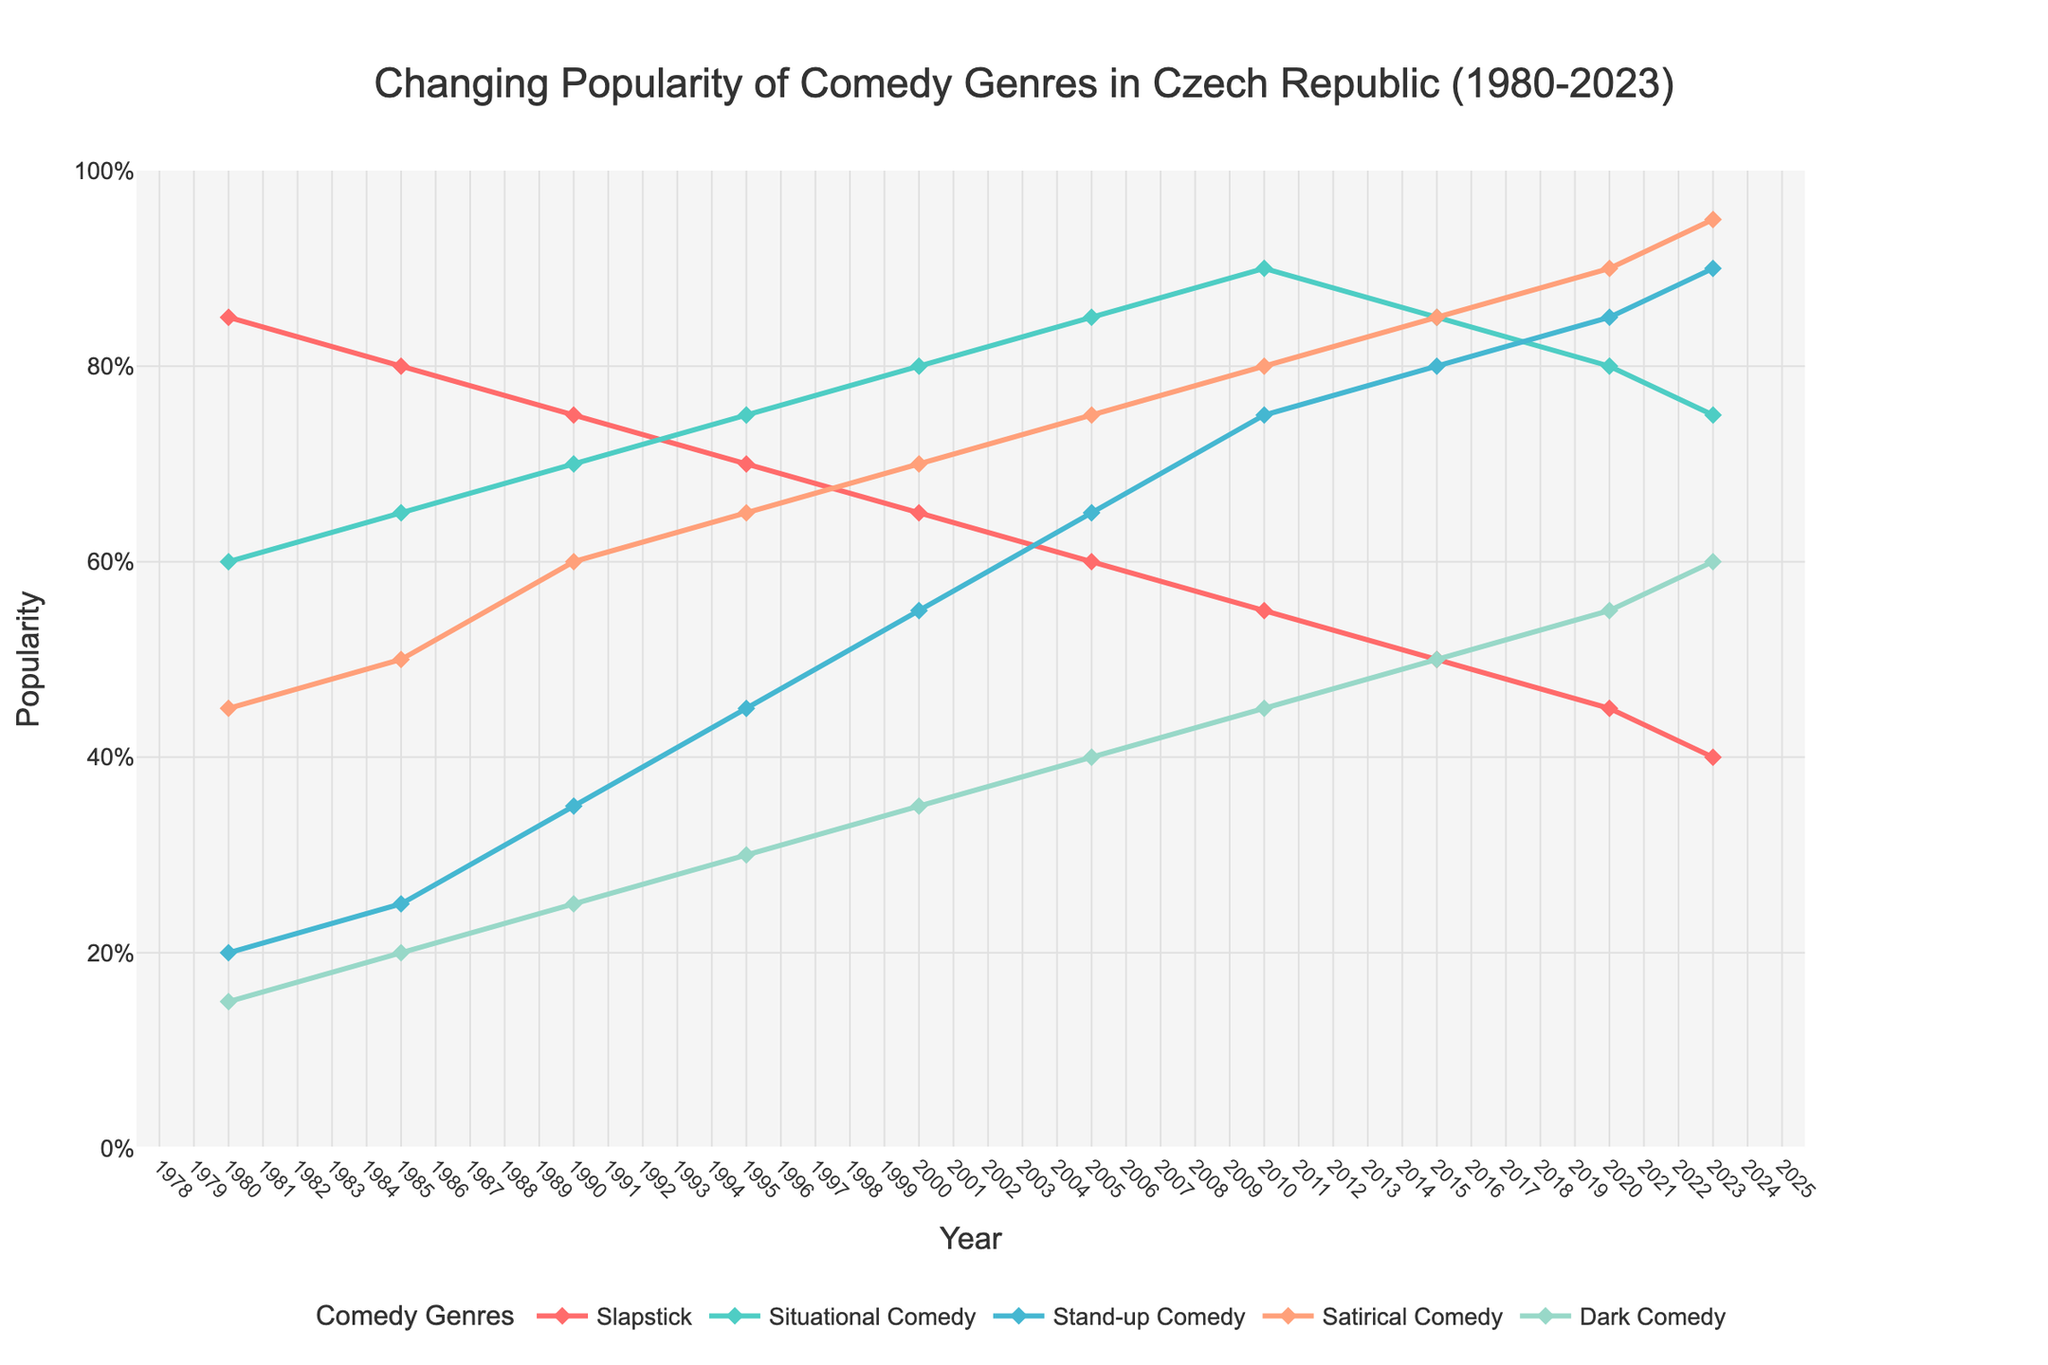What genre shows a steady decline in popularity from 1980 to 2023? Slapstick comedy. Its popularity decreases from 85% in 1980 to 40% in 2023.
Answer: Slapstick Comedy Which comedy genre was the most popular in 1980? By looking at the y-values in 1980, Slapstick Comedy is the highest at 85.
Answer: Slapstick Comedy Has Stand-up Comedy ever surpassed Situational Comedy in popularity? No, Stand-up Comedy shows consistent growth but remains below Situational Comedy at every data point.
Answer: No Compare the popularity of Dark Comedy and Satirical Comedy in 2010. Which is higher? In 2010, the y-values of Satirical Comedy (80) are higher than Dark Comedy (45).
Answer: Satirical Comedy Which genre has the highest increase in popularity from 1980 to 2023? Satirical Comedy increased from 45 in 1980 to 95 in 2023, which is the highest increase of 50.
Answer: Satirical Comedy In which year did Situational Comedy reach its peak popularity? By tracing the peak point in the Situational Comedy line, the peak is 2010 with a y-value of 90.
Answer: 2010 What is the average popularity of Slapstick Comedy from 1980 to 2023? Sum all popularity values of Slapstick Comedy and divide by the number of years: (85+80+75+70+65+60+55+50+45+40) / 10 = 62.5
Answer: 62.5 How does the popularity of Dark Comedy compare to Satirical Comedy in 2023? In 2023, Dark Comedy has a popularity of 60, whereas Satirical Comedy has 95, making Satirical Comedy more popular.
Answer: Satirical Comedy What is the difference in popularity between the highest and lowest genres in 2005? In 2005, the highest is Situational Comedy (85) and the lowest is Slapstick Comedy (60). The difference is 85 - 60 = 25
Answer: 25 Which comedy genre shows the most steady increase in popularity from 1980 to 2023? Satirical Comedy shows a consistent upward trend from 45 in 1980 to 95 in 2023, without any decline.
Answer: Satirical Comedy 